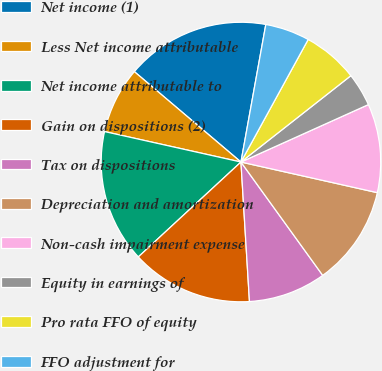Convert chart to OTSL. <chart><loc_0><loc_0><loc_500><loc_500><pie_chart><fcel>Net income (1)<fcel>Less Net income attributable<fcel>Net income attributable to<fcel>Gain on dispositions (2)<fcel>Tax on dispositions<fcel>Depreciation and amortization<fcel>Non-cash impairment expense<fcel>Equity in earnings of<fcel>Pro rata FFO of equity<fcel>FFO adjustment for<nl><fcel>16.66%<fcel>7.7%<fcel>15.38%<fcel>14.1%<fcel>8.98%<fcel>11.54%<fcel>10.26%<fcel>3.86%<fcel>6.42%<fcel>5.14%<nl></chart> 